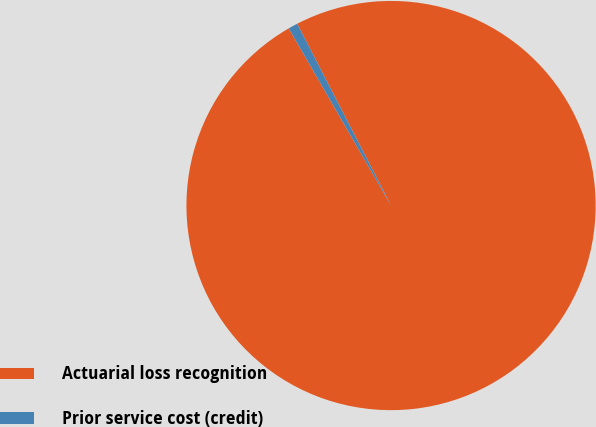Convert chart to OTSL. <chart><loc_0><loc_0><loc_500><loc_500><pie_chart><fcel>Actuarial loss recognition<fcel>Prior service cost (credit)<nl><fcel>99.25%<fcel>0.75%<nl></chart> 